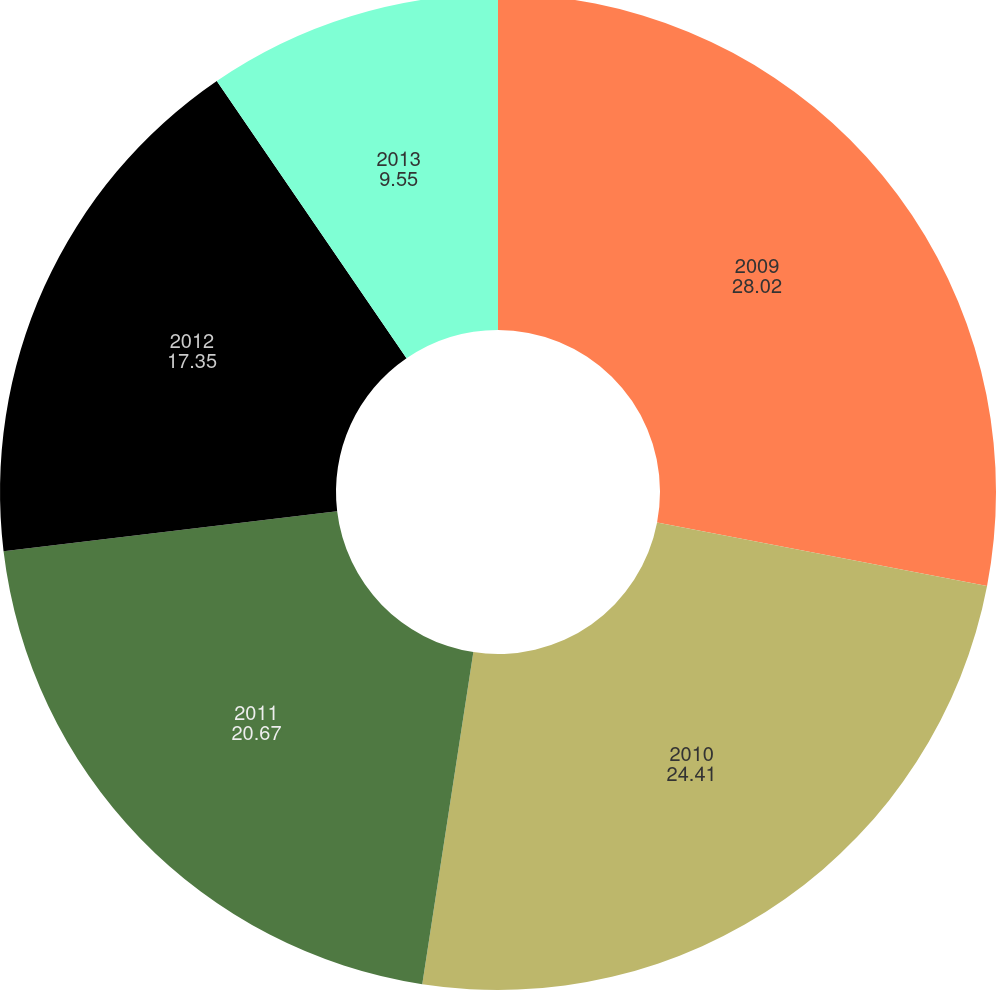<chart> <loc_0><loc_0><loc_500><loc_500><pie_chart><fcel>2009<fcel>2010<fcel>2011<fcel>2012<fcel>2013<nl><fcel>28.02%<fcel>24.41%<fcel>20.67%<fcel>17.35%<fcel>9.55%<nl></chart> 